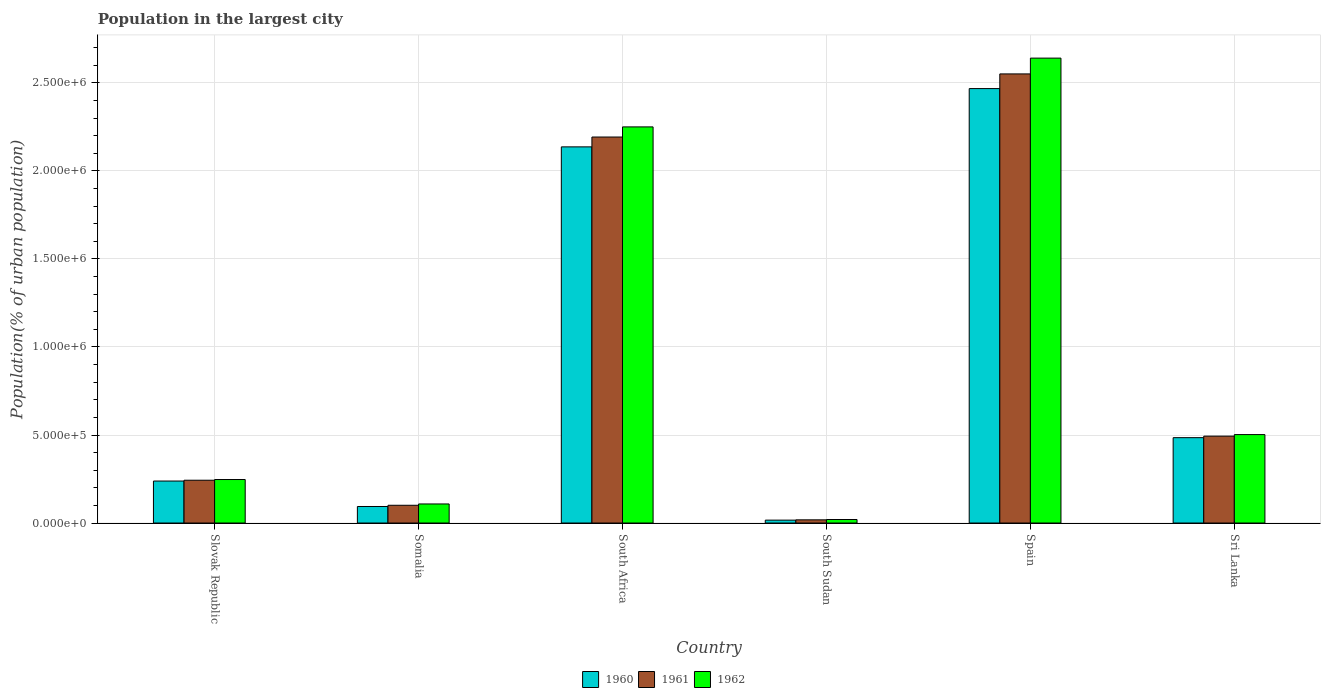How many different coloured bars are there?
Your response must be concise. 3. How many bars are there on the 6th tick from the right?
Keep it short and to the point. 3. What is the label of the 6th group of bars from the left?
Give a very brief answer. Sri Lanka. In how many cases, is the number of bars for a given country not equal to the number of legend labels?
Your answer should be compact. 0. What is the population in the largest city in 1961 in Slovak Republic?
Offer a terse response. 2.43e+05. Across all countries, what is the maximum population in the largest city in 1960?
Keep it short and to the point. 2.47e+06. Across all countries, what is the minimum population in the largest city in 1962?
Offer a very short reply. 2.00e+04. In which country was the population in the largest city in 1960 minimum?
Your response must be concise. South Sudan. What is the total population in the largest city in 1961 in the graph?
Ensure brevity in your answer.  5.60e+06. What is the difference between the population in the largest city in 1961 in South Sudan and that in Sri Lanka?
Offer a very short reply. -4.75e+05. What is the difference between the population in the largest city in 1962 in Sri Lanka and the population in the largest city in 1960 in Spain?
Offer a very short reply. -1.97e+06. What is the average population in the largest city in 1961 per country?
Keep it short and to the point. 9.33e+05. What is the difference between the population in the largest city of/in 1962 and population in the largest city of/in 1961 in Somalia?
Provide a succinct answer. 7482. What is the ratio of the population in the largest city in 1960 in Slovak Republic to that in South Sudan?
Ensure brevity in your answer.  14.48. What is the difference between the highest and the second highest population in the largest city in 1961?
Provide a succinct answer. -2.06e+06. What is the difference between the highest and the lowest population in the largest city in 1962?
Provide a succinct answer. 2.62e+06. In how many countries, is the population in the largest city in 1962 greater than the average population in the largest city in 1962 taken over all countries?
Your response must be concise. 2. Is the sum of the population in the largest city in 1960 in Somalia and Sri Lanka greater than the maximum population in the largest city in 1961 across all countries?
Give a very brief answer. No. What does the 2nd bar from the left in Somalia represents?
Keep it short and to the point. 1961. Is it the case that in every country, the sum of the population in the largest city in 1962 and population in the largest city in 1960 is greater than the population in the largest city in 1961?
Your answer should be compact. Yes. How many bars are there?
Give a very brief answer. 18. How many countries are there in the graph?
Make the answer very short. 6. What is the difference between two consecutive major ticks on the Y-axis?
Your response must be concise. 5.00e+05. Are the values on the major ticks of Y-axis written in scientific E-notation?
Keep it short and to the point. Yes. Does the graph contain any zero values?
Give a very brief answer. No. Does the graph contain grids?
Provide a succinct answer. Yes. Where does the legend appear in the graph?
Offer a terse response. Bottom center. How many legend labels are there?
Provide a succinct answer. 3. How are the legend labels stacked?
Make the answer very short. Horizontal. What is the title of the graph?
Keep it short and to the point. Population in the largest city. What is the label or title of the Y-axis?
Provide a succinct answer. Population(% of urban population). What is the Population(% of urban population) in 1960 in Slovak Republic?
Offer a very short reply. 2.39e+05. What is the Population(% of urban population) of 1961 in Slovak Republic?
Your answer should be very brief. 2.43e+05. What is the Population(% of urban population) of 1962 in Slovak Republic?
Your response must be concise. 2.47e+05. What is the Population(% of urban population) in 1960 in Somalia?
Provide a short and direct response. 9.39e+04. What is the Population(% of urban population) in 1961 in Somalia?
Give a very brief answer. 1.01e+05. What is the Population(% of urban population) in 1962 in Somalia?
Give a very brief answer. 1.08e+05. What is the Population(% of urban population) of 1960 in South Africa?
Your answer should be compact. 2.14e+06. What is the Population(% of urban population) of 1961 in South Africa?
Offer a terse response. 2.19e+06. What is the Population(% of urban population) in 1962 in South Africa?
Provide a succinct answer. 2.25e+06. What is the Population(% of urban population) of 1960 in South Sudan?
Keep it short and to the point. 1.65e+04. What is the Population(% of urban population) of 1961 in South Sudan?
Keep it short and to the point. 1.82e+04. What is the Population(% of urban population) of 1960 in Spain?
Give a very brief answer. 2.47e+06. What is the Population(% of urban population) in 1961 in Spain?
Your answer should be compact. 2.55e+06. What is the Population(% of urban population) of 1962 in Spain?
Offer a very short reply. 2.64e+06. What is the Population(% of urban population) of 1960 in Sri Lanka?
Provide a short and direct response. 4.85e+05. What is the Population(% of urban population) in 1961 in Sri Lanka?
Offer a terse response. 4.94e+05. What is the Population(% of urban population) in 1962 in Sri Lanka?
Provide a succinct answer. 5.02e+05. Across all countries, what is the maximum Population(% of urban population) in 1960?
Offer a terse response. 2.47e+06. Across all countries, what is the maximum Population(% of urban population) of 1961?
Offer a very short reply. 2.55e+06. Across all countries, what is the maximum Population(% of urban population) in 1962?
Give a very brief answer. 2.64e+06. Across all countries, what is the minimum Population(% of urban population) of 1960?
Your answer should be compact. 1.65e+04. Across all countries, what is the minimum Population(% of urban population) in 1961?
Your answer should be compact. 1.82e+04. Across all countries, what is the minimum Population(% of urban population) in 1962?
Your answer should be compact. 2.00e+04. What is the total Population(% of urban population) of 1960 in the graph?
Offer a terse response. 5.44e+06. What is the total Population(% of urban population) in 1961 in the graph?
Offer a terse response. 5.60e+06. What is the total Population(% of urban population) in 1962 in the graph?
Your answer should be compact. 5.77e+06. What is the difference between the Population(% of urban population) of 1960 in Slovak Republic and that in Somalia?
Your answer should be compact. 1.45e+05. What is the difference between the Population(% of urban population) of 1961 in Slovak Republic and that in Somalia?
Your response must be concise. 1.42e+05. What is the difference between the Population(% of urban population) in 1962 in Slovak Republic and that in Somalia?
Your answer should be compact. 1.39e+05. What is the difference between the Population(% of urban population) of 1960 in Slovak Republic and that in South Africa?
Make the answer very short. -1.90e+06. What is the difference between the Population(% of urban population) in 1961 in Slovak Republic and that in South Africa?
Ensure brevity in your answer.  -1.95e+06. What is the difference between the Population(% of urban population) in 1962 in Slovak Republic and that in South Africa?
Ensure brevity in your answer.  -2.00e+06. What is the difference between the Population(% of urban population) of 1960 in Slovak Republic and that in South Sudan?
Give a very brief answer. 2.22e+05. What is the difference between the Population(% of urban population) of 1961 in Slovak Republic and that in South Sudan?
Give a very brief answer. 2.25e+05. What is the difference between the Population(% of urban population) of 1962 in Slovak Republic and that in South Sudan?
Make the answer very short. 2.27e+05. What is the difference between the Population(% of urban population) in 1960 in Slovak Republic and that in Spain?
Your response must be concise. -2.23e+06. What is the difference between the Population(% of urban population) of 1961 in Slovak Republic and that in Spain?
Keep it short and to the point. -2.31e+06. What is the difference between the Population(% of urban population) in 1962 in Slovak Republic and that in Spain?
Your answer should be compact. -2.39e+06. What is the difference between the Population(% of urban population) of 1960 in Slovak Republic and that in Sri Lanka?
Your response must be concise. -2.46e+05. What is the difference between the Population(% of urban population) in 1961 in Slovak Republic and that in Sri Lanka?
Provide a succinct answer. -2.50e+05. What is the difference between the Population(% of urban population) of 1962 in Slovak Republic and that in Sri Lanka?
Provide a succinct answer. -2.55e+05. What is the difference between the Population(% of urban population) in 1960 in Somalia and that in South Africa?
Provide a succinct answer. -2.04e+06. What is the difference between the Population(% of urban population) in 1961 in Somalia and that in South Africa?
Ensure brevity in your answer.  -2.09e+06. What is the difference between the Population(% of urban population) in 1962 in Somalia and that in South Africa?
Offer a very short reply. -2.14e+06. What is the difference between the Population(% of urban population) of 1960 in Somalia and that in South Sudan?
Offer a very short reply. 7.74e+04. What is the difference between the Population(% of urban population) in 1961 in Somalia and that in South Sudan?
Ensure brevity in your answer.  8.27e+04. What is the difference between the Population(% of urban population) in 1962 in Somalia and that in South Sudan?
Make the answer very short. 8.84e+04. What is the difference between the Population(% of urban population) of 1960 in Somalia and that in Spain?
Keep it short and to the point. -2.37e+06. What is the difference between the Population(% of urban population) of 1961 in Somalia and that in Spain?
Keep it short and to the point. -2.45e+06. What is the difference between the Population(% of urban population) of 1962 in Somalia and that in Spain?
Keep it short and to the point. -2.53e+06. What is the difference between the Population(% of urban population) in 1960 in Somalia and that in Sri Lanka?
Keep it short and to the point. -3.91e+05. What is the difference between the Population(% of urban population) in 1961 in Somalia and that in Sri Lanka?
Your answer should be very brief. -3.93e+05. What is the difference between the Population(% of urban population) in 1962 in Somalia and that in Sri Lanka?
Offer a very short reply. -3.94e+05. What is the difference between the Population(% of urban population) of 1960 in South Africa and that in South Sudan?
Offer a terse response. 2.12e+06. What is the difference between the Population(% of urban population) in 1961 in South Africa and that in South Sudan?
Your answer should be very brief. 2.17e+06. What is the difference between the Population(% of urban population) in 1962 in South Africa and that in South Sudan?
Your answer should be compact. 2.23e+06. What is the difference between the Population(% of urban population) of 1960 in South Africa and that in Spain?
Ensure brevity in your answer.  -3.31e+05. What is the difference between the Population(% of urban population) of 1961 in South Africa and that in Spain?
Keep it short and to the point. -3.59e+05. What is the difference between the Population(% of urban population) of 1962 in South Africa and that in Spain?
Provide a succinct answer. -3.91e+05. What is the difference between the Population(% of urban population) of 1960 in South Africa and that in Sri Lanka?
Offer a terse response. 1.65e+06. What is the difference between the Population(% of urban population) in 1961 in South Africa and that in Sri Lanka?
Ensure brevity in your answer.  1.70e+06. What is the difference between the Population(% of urban population) in 1962 in South Africa and that in Sri Lanka?
Your response must be concise. 1.75e+06. What is the difference between the Population(% of urban population) of 1960 in South Sudan and that in Spain?
Make the answer very short. -2.45e+06. What is the difference between the Population(% of urban population) in 1961 in South Sudan and that in Spain?
Provide a short and direct response. -2.53e+06. What is the difference between the Population(% of urban population) of 1962 in South Sudan and that in Spain?
Provide a succinct answer. -2.62e+06. What is the difference between the Population(% of urban population) of 1960 in South Sudan and that in Sri Lanka?
Provide a short and direct response. -4.68e+05. What is the difference between the Population(% of urban population) in 1961 in South Sudan and that in Sri Lanka?
Your response must be concise. -4.75e+05. What is the difference between the Population(% of urban population) of 1962 in South Sudan and that in Sri Lanka?
Offer a very short reply. -4.82e+05. What is the difference between the Population(% of urban population) of 1960 in Spain and that in Sri Lanka?
Ensure brevity in your answer.  1.98e+06. What is the difference between the Population(% of urban population) of 1961 in Spain and that in Sri Lanka?
Your answer should be very brief. 2.06e+06. What is the difference between the Population(% of urban population) in 1962 in Spain and that in Sri Lanka?
Your response must be concise. 2.14e+06. What is the difference between the Population(% of urban population) of 1960 in Slovak Republic and the Population(% of urban population) of 1961 in Somalia?
Your answer should be very brief. 1.38e+05. What is the difference between the Population(% of urban population) in 1960 in Slovak Republic and the Population(% of urban population) in 1962 in Somalia?
Keep it short and to the point. 1.30e+05. What is the difference between the Population(% of urban population) in 1961 in Slovak Republic and the Population(% of urban population) in 1962 in Somalia?
Offer a very short reply. 1.35e+05. What is the difference between the Population(% of urban population) in 1960 in Slovak Republic and the Population(% of urban population) in 1961 in South Africa?
Provide a succinct answer. -1.95e+06. What is the difference between the Population(% of urban population) in 1960 in Slovak Republic and the Population(% of urban population) in 1962 in South Africa?
Provide a short and direct response. -2.01e+06. What is the difference between the Population(% of urban population) of 1961 in Slovak Republic and the Population(% of urban population) of 1962 in South Africa?
Your answer should be compact. -2.01e+06. What is the difference between the Population(% of urban population) in 1960 in Slovak Republic and the Population(% of urban population) in 1961 in South Sudan?
Offer a very short reply. 2.20e+05. What is the difference between the Population(% of urban population) of 1960 in Slovak Republic and the Population(% of urban population) of 1962 in South Sudan?
Give a very brief answer. 2.19e+05. What is the difference between the Population(% of urban population) in 1961 in Slovak Republic and the Population(% of urban population) in 1962 in South Sudan?
Keep it short and to the point. 2.23e+05. What is the difference between the Population(% of urban population) in 1960 in Slovak Republic and the Population(% of urban population) in 1961 in Spain?
Keep it short and to the point. -2.31e+06. What is the difference between the Population(% of urban population) of 1960 in Slovak Republic and the Population(% of urban population) of 1962 in Spain?
Ensure brevity in your answer.  -2.40e+06. What is the difference between the Population(% of urban population) of 1961 in Slovak Republic and the Population(% of urban population) of 1962 in Spain?
Ensure brevity in your answer.  -2.40e+06. What is the difference between the Population(% of urban population) in 1960 in Slovak Republic and the Population(% of urban population) in 1961 in Sri Lanka?
Offer a very short reply. -2.55e+05. What is the difference between the Population(% of urban population) in 1960 in Slovak Republic and the Population(% of urban population) in 1962 in Sri Lanka?
Offer a terse response. -2.64e+05. What is the difference between the Population(% of urban population) in 1961 in Slovak Republic and the Population(% of urban population) in 1962 in Sri Lanka?
Provide a succinct answer. -2.59e+05. What is the difference between the Population(% of urban population) in 1960 in Somalia and the Population(% of urban population) in 1961 in South Africa?
Make the answer very short. -2.10e+06. What is the difference between the Population(% of urban population) in 1960 in Somalia and the Population(% of urban population) in 1962 in South Africa?
Offer a terse response. -2.16e+06. What is the difference between the Population(% of urban population) in 1961 in Somalia and the Population(% of urban population) in 1962 in South Africa?
Provide a succinct answer. -2.15e+06. What is the difference between the Population(% of urban population) in 1960 in Somalia and the Population(% of urban population) in 1961 in South Sudan?
Your answer should be very brief. 7.58e+04. What is the difference between the Population(% of urban population) of 1960 in Somalia and the Population(% of urban population) of 1962 in South Sudan?
Offer a terse response. 7.39e+04. What is the difference between the Population(% of urban population) in 1961 in Somalia and the Population(% of urban population) in 1962 in South Sudan?
Offer a terse response. 8.09e+04. What is the difference between the Population(% of urban population) of 1960 in Somalia and the Population(% of urban population) of 1961 in Spain?
Your answer should be very brief. -2.46e+06. What is the difference between the Population(% of urban population) in 1960 in Somalia and the Population(% of urban population) in 1962 in Spain?
Offer a very short reply. -2.55e+06. What is the difference between the Population(% of urban population) of 1961 in Somalia and the Population(% of urban population) of 1962 in Spain?
Offer a terse response. -2.54e+06. What is the difference between the Population(% of urban population) in 1960 in Somalia and the Population(% of urban population) in 1961 in Sri Lanka?
Provide a short and direct response. -4.00e+05. What is the difference between the Population(% of urban population) of 1960 in Somalia and the Population(% of urban population) of 1962 in Sri Lanka?
Your answer should be very brief. -4.09e+05. What is the difference between the Population(% of urban population) of 1961 in Somalia and the Population(% of urban population) of 1962 in Sri Lanka?
Keep it short and to the point. -4.02e+05. What is the difference between the Population(% of urban population) in 1960 in South Africa and the Population(% of urban population) in 1961 in South Sudan?
Provide a succinct answer. 2.12e+06. What is the difference between the Population(% of urban population) of 1960 in South Africa and the Population(% of urban population) of 1962 in South Sudan?
Make the answer very short. 2.12e+06. What is the difference between the Population(% of urban population) of 1961 in South Africa and the Population(% of urban population) of 1962 in South Sudan?
Offer a terse response. 2.17e+06. What is the difference between the Population(% of urban population) in 1960 in South Africa and the Population(% of urban population) in 1961 in Spain?
Provide a succinct answer. -4.14e+05. What is the difference between the Population(% of urban population) in 1960 in South Africa and the Population(% of urban population) in 1962 in Spain?
Offer a very short reply. -5.04e+05. What is the difference between the Population(% of urban population) in 1961 in South Africa and the Population(% of urban population) in 1962 in Spain?
Offer a terse response. -4.48e+05. What is the difference between the Population(% of urban population) of 1960 in South Africa and the Population(% of urban population) of 1961 in Sri Lanka?
Your answer should be compact. 1.64e+06. What is the difference between the Population(% of urban population) of 1960 in South Africa and the Population(% of urban population) of 1962 in Sri Lanka?
Offer a very short reply. 1.63e+06. What is the difference between the Population(% of urban population) in 1961 in South Africa and the Population(% of urban population) in 1962 in Sri Lanka?
Ensure brevity in your answer.  1.69e+06. What is the difference between the Population(% of urban population) in 1960 in South Sudan and the Population(% of urban population) in 1961 in Spain?
Keep it short and to the point. -2.53e+06. What is the difference between the Population(% of urban population) in 1960 in South Sudan and the Population(% of urban population) in 1962 in Spain?
Your answer should be very brief. -2.62e+06. What is the difference between the Population(% of urban population) in 1961 in South Sudan and the Population(% of urban population) in 1962 in Spain?
Provide a succinct answer. -2.62e+06. What is the difference between the Population(% of urban population) of 1960 in South Sudan and the Population(% of urban population) of 1961 in Sri Lanka?
Keep it short and to the point. -4.77e+05. What is the difference between the Population(% of urban population) in 1960 in South Sudan and the Population(% of urban population) in 1962 in Sri Lanka?
Give a very brief answer. -4.86e+05. What is the difference between the Population(% of urban population) of 1961 in South Sudan and the Population(% of urban population) of 1962 in Sri Lanka?
Provide a short and direct response. -4.84e+05. What is the difference between the Population(% of urban population) of 1960 in Spain and the Population(% of urban population) of 1961 in Sri Lanka?
Offer a very short reply. 1.97e+06. What is the difference between the Population(% of urban population) of 1960 in Spain and the Population(% of urban population) of 1962 in Sri Lanka?
Keep it short and to the point. 1.97e+06. What is the difference between the Population(% of urban population) in 1961 in Spain and the Population(% of urban population) in 1962 in Sri Lanka?
Keep it short and to the point. 2.05e+06. What is the average Population(% of urban population) in 1960 per country?
Make the answer very short. 9.06e+05. What is the average Population(% of urban population) of 1961 per country?
Your answer should be compact. 9.33e+05. What is the average Population(% of urban population) of 1962 per country?
Your response must be concise. 9.62e+05. What is the difference between the Population(% of urban population) of 1960 and Population(% of urban population) of 1961 in Slovak Republic?
Offer a very short reply. -4614. What is the difference between the Population(% of urban population) in 1960 and Population(% of urban population) in 1962 in Slovak Republic?
Keep it short and to the point. -8657. What is the difference between the Population(% of urban population) in 1961 and Population(% of urban population) in 1962 in Slovak Republic?
Give a very brief answer. -4043. What is the difference between the Population(% of urban population) in 1960 and Population(% of urban population) in 1961 in Somalia?
Your answer should be very brief. -6956. What is the difference between the Population(% of urban population) in 1960 and Population(% of urban population) in 1962 in Somalia?
Provide a short and direct response. -1.44e+04. What is the difference between the Population(% of urban population) of 1961 and Population(% of urban population) of 1962 in Somalia?
Offer a terse response. -7482. What is the difference between the Population(% of urban population) of 1960 and Population(% of urban population) of 1961 in South Africa?
Your answer should be compact. -5.59e+04. What is the difference between the Population(% of urban population) in 1960 and Population(% of urban population) in 1962 in South Africa?
Provide a short and direct response. -1.14e+05. What is the difference between the Population(% of urban population) of 1961 and Population(% of urban population) of 1962 in South Africa?
Your answer should be compact. -5.76e+04. What is the difference between the Population(% of urban population) of 1960 and Population(% of urban population) of 1961 in South Sudan?
Keep it short and to the point. -1675. What is the difference between the Population(% of urban population) of 1960 and Population(% of urban population) of 1962 in South Sudan?
Your response must be concise. -3523. What is the difference between the Population(% of urban population) in 1961 and Population(% of urban population) in 1962 in South Sudan?
Provide a succinct answer. -1848. What is the difference between the Population(% of urban population) in 1960 and Population(% of urban population) in 1961 in Spain?
Make the answer very short. -8.34e+04. What is the difference between the Population(% of urban population) in 1960 and Population(% of urban population) in 1962 in Spain?
Your answer should be very brief. -1.73e+05. What is the difference between the Population(% of urban population) of 1961 and Population(% of urban population) of 1962 in Spain?
Your answer should be compact. -8.97e+04. What is the difference between the Population(% of urban population) in 1960 and Population(% of urban population) in 1961 in Sri Lanka?
Provide a short and direct response. -8675. What is the difference between the Population(% of urban population) in 1960 and Population(% of urban population) in 1962 in Sri Lanka?
Your answer should be compact. -1.75e+04. What is the difference between the Population(% of urban population) of 1961 and Population(% of urban population) of 1962 in Sri Lanka?
Your response must be concise. -8842. What is the ratio of the Population(% of urban population) of 1960 in Slovak Republic to that in Somalia?
Ensure brevity in your answer.  2.54. What is the ratio of the Population(% of urban population) in 1961 in Slovak Republic to that in Somalia?
Ensure brevity in your answer.  2.41. What is the ratio of the Population(% of urban population) of 1962 in Slovak Republic to that in Somalia?
Ensure brevity in your answer.  2.28. What is the ratio of the Population(% of urban population) in 1960 in Slovak Republic to that in South Africa?
Make the answer very short. 0.11. What is the ratio of the Population(% of urban population) of 1961 in Slovak Republic to that in South Africa?
Keep it short and to the point. 0.11. What is the ratio of the Population(% of urban population) in 1962 in Slovak Republic to that in South Africa?
Ensure brevity in your answer.  0.11. What is the ratio of the Population(% of urban population) in 1960 in Slovak Republic to that in South Sudan?
Provide a succinct answer. 14.48. What is the ratio of the Population(% of urban population) in 1961 in Slovak Republic to that in South Sudan?
Your response must be concise. 13.39. What is the ratio of the Population(% of urban population) of 1962 in Slovak Republic to that in South Sudan?
Offer a very short reply. 12.36. What is the ratio of the Population(% of urban population) in 1960 in Slovak Republic to that in Spain?
Ensure brevity in your answer.  0.1. What is the ratio of the Population(% of urban population) of 1961 in Slovak Republic to that in Spain?
Give a very brief answer. 0.1. What is the ratio of the Population(% of urban population) of 1962 in Slovak Republic to that in Spain?
Keep it short and to the point. 0.09. What is the ratio of the Population(% of urban population) of 1960 in Slovak Republic to that in Sri Lanka?
Offer a very short reply. 0.49. What is the ratio of the Population(% of urban population) in 1961 in Slovak Republic to that in Sri Lanka?
Your answer should be compact. 0.49. What is the ratio of the Population(% of urban population) in 1962 in Slovak Republic to that in Sri Lanka?
Offer a terse response. 0.49. What is the ratio of the Population(% of urban population) in 1960 in Somalia to that in South Africa?
Make the answer very short. 0.04. What is the ratio of the Population(% of urban population) of 1961 in Somalia to that in South Africa?
Provide a succinct answer. 0.05. What is the ratio of the Population(% of urban population) in 1962 in Somalia to that in South Africa?
Ensure brevity in your answer.  0.05. What is the ratio of the Population(% of urban population) of 1960 in Somalia to that in South Sudan?
Offer a terse response. 5.7. What is the ratio of the Population(% of urban population) in 1961 in Somalia to that in South Sudan?
Give a very brief answer. 5.56. What is the ratio of the Population(% of urban population) in 1962 in Somalia to that in South Sudan?
Offer a very short reply. 5.42. What is the ratio of the Population(% of urban population) in 1960 in Somalia to that in Spain?
Make the answer very short. 0.04. What is the ratio of the Population(% of urban population) of 1961 in Somalia to that in Spain?
Ensure brevity in your answer.  0.04. What is the ratio of the Population(% of urban population) of 1962 in Somalia to that in Spain?
Offer a very short reply. 0.04. What is the ratio of the Population(% of urban population) in 1960 in Somalia to that in Sri Lanka?
Provide a short and direct response. 0.19. What is the ratio of the Population(% of urban population) of 1961 in Somalia to that in Sri Lanka?
Your answer should be compact. 0.2. What is the ratio of the Population(% of urban population) in 1962 in Somalia to that in Sri Lanka?
Give a very brief answer. 0.22. What is the ratio of the Population(% of urban population) of 1960 in South Africa to that in South Sudan?
Ensure brevity in your answer.  129.69. What is the ratio of the Population(% of urban population) of 1961 in South Africa to that in South Sudan?
Your response must be concise. 120.8. What is the ratio of the Population(% of urban population) in 1962 in South Africa to that in South Sudan?
Keep it short and to the point. 112.52. What is the ratio of the Population(% of urban population) of 1960 in South Africa to that in Spain?
Give a very brief answer. 0.87. What is the ratio of the Population(% of urban population) of 1961 in South Africa to that in Spain?
Give a very brief answer. 0.86. What is the ratio of the Population(% of urban population) in 1962 in South Africa to that in Spain?
Your answer should be very brief. 0.85. What is the ratio of the Population(% of urban population) of 1960 in South Africa to that in Sri Lanka?
Make the answer very short. 4.41. What is the ratio of the Population(% of urban population) of 1961 in South Africa to that in Sri Lanka?
Offer a very short reply. 4.44. What is the ratio of the Population(% of urban population) in 1962 in South Africa to that in Sri Lanka?
Your answer should be very brief. 4.48. What is the ratio of the Population(% of urban population) of 1960 in South Sudan to that in Spain?
Provide a short and direct response. 0.01. What is the ratio of the Population(% of urban population) in 1961 in South Sudan to that in Spain?
Your answer should be compact. 0.01. What is the ratio of the Population(% of urban population) of 1962 in South Sudan to that in Spain?
Ensure brevity in your answer.  0.01. What is the ratio of the Population(% of urban population) of 1960 in South Sudan to that in Sri Lanka?
Provide a succinct answer. 0.03. What is the ratio of the Population(% of urban population) in 1961 in South Sudan to that in Sri Lanka?
Provide a short and direct response. 0.04. What is the ratio of the Population(% of urban population) of 1962 in South Sudan to that in Sri Lanka?
Give a very brief answer. 0.04. What is the ratio of the Population(% of urban population) in 1960 in Spain to that in Sri Lanka?
Ensure brevity in your answer.  5.09. What is the ratio of the Population(% of urban population) of 1961 in Spain to that in Sri Lanka?
Provide a short and direct response. 5.17. What is the ratio of the Population(% of urban population) of 1962 in Spain to that in Sri Lanka?
Your answer should be compact. 5.26. What is the difference between the highest and the second highest Population(% of urban population) in 1960?
Your response must be concise. 3.31e+05. What is the difference between the highest and the second highest Population(% of urban population) of 1961?
Provide a short and direct response. 3.59e+05. What is the difference between the highest and the second highest Population(% of urban population) in 1962?
Provide a short and direct response. 3.91e+05. What is the difference between the highest and the lowest Population(% of urban population) of 1960?
Offer a very short reply. 2.45e+06. What is the difference between the highest and the lowest Population(% of urban population) in 1961?
Offer a very short reply. 2.53e+06. What is the difference between the highest and the lowest Population(% of urban population) in 1962?
Ensure brevity in your answer.  2.62e+06. 